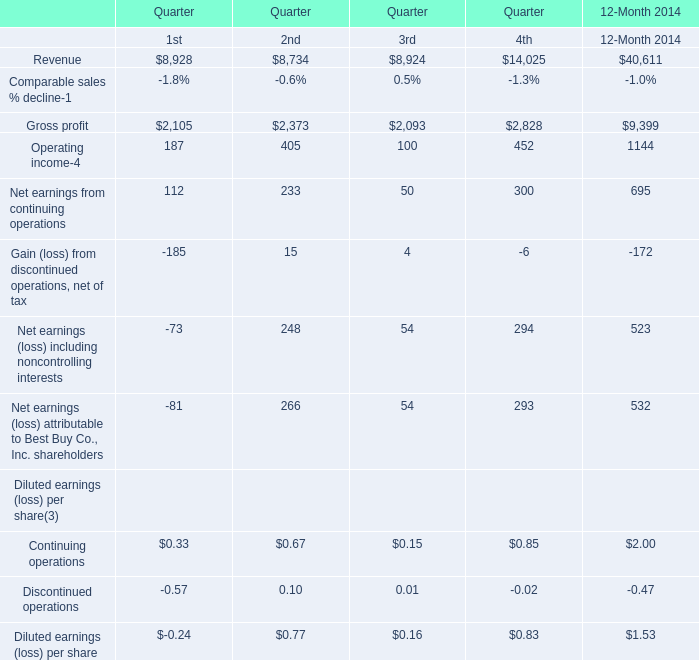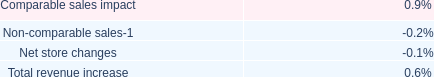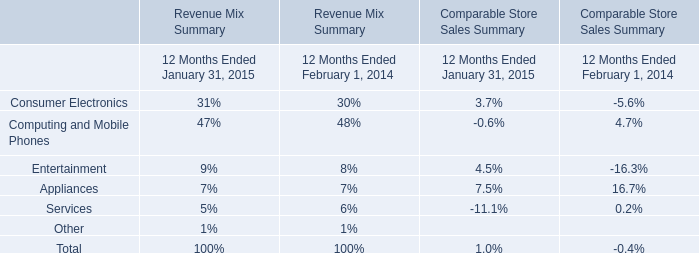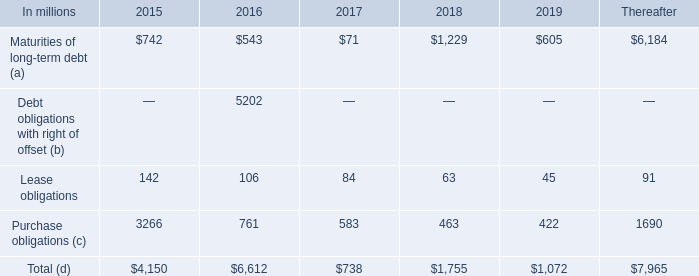How many gross profit are greater than 2000 in 2014? 
Answer: 4. 